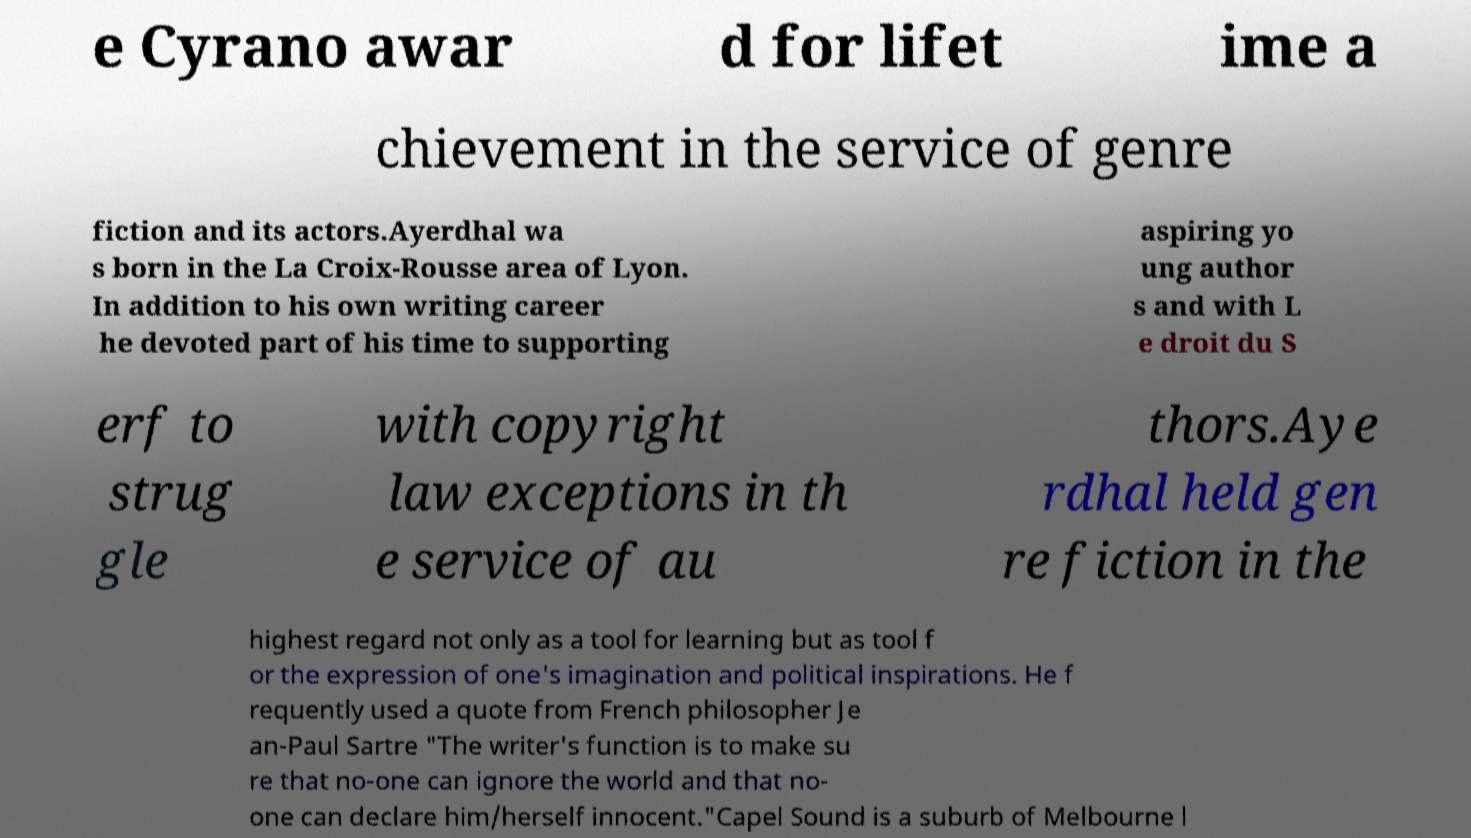Please read and relay the text visible in this image. What does it say? e Cyrano awar d for lifet ime a chievement in the service of genre fiction and its actors.Ayerdhal wa s born in the La Croix-Rousse area of Lyon. In addition to his own writing career he devoted part of his time to supporting aspiring yo ung author s and with L e droit du S erf to strug gle with copyright law exceptions in th e service of au thors.Aye rdhal held gen re fiction in the highest regard not only as a tool for learning but as tool f or the expression of one's imagination and political inspirations. He f requently used a quote from French philosopher Je an-Paul Sartre "The writer's function is to make su re that no-one can ignore the world and that no- one can declare him/herself innocent."Capel Sound is a suburb of Melbourne l 